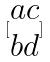Convert formula to latex. <formula><loc_0><loc_0><loc_500><loc_500>[ \begin{matrix} a c \\ b d \end{matrix} ]</formula> 